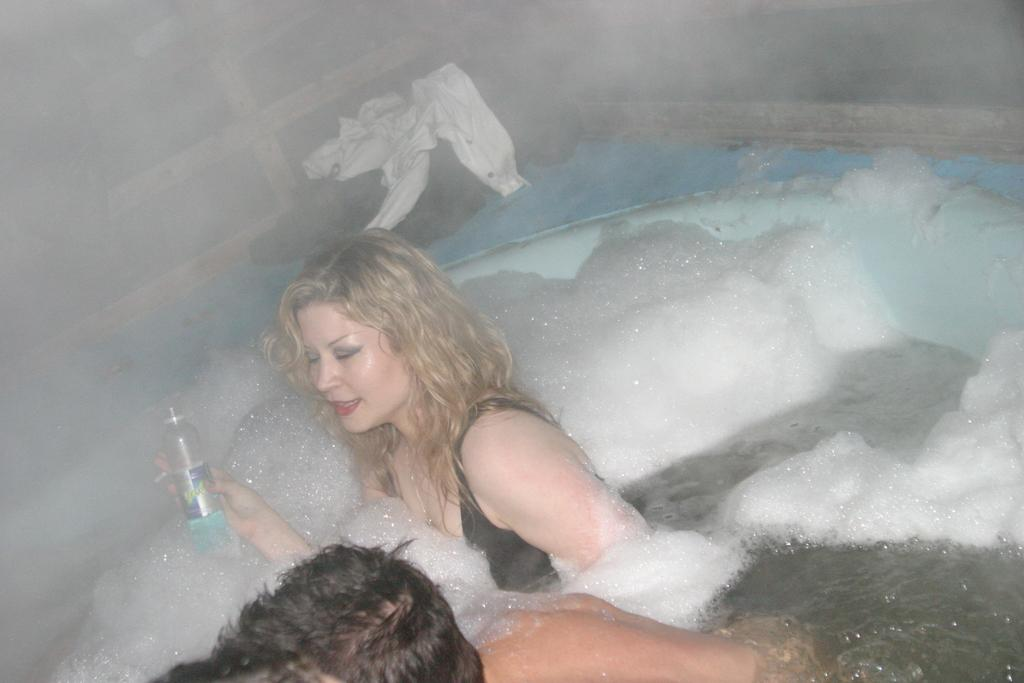Who is present in the image? There is a woman in the image. What is the woman holding in the image? The woman is holding a water bottle. What can be seen in the background of the image? There is a bathtub in the image. What year is depicted in the image? The image does not depict a specific year; it is a photograph of a woman holding a water bottle and standing near a bathtub. 